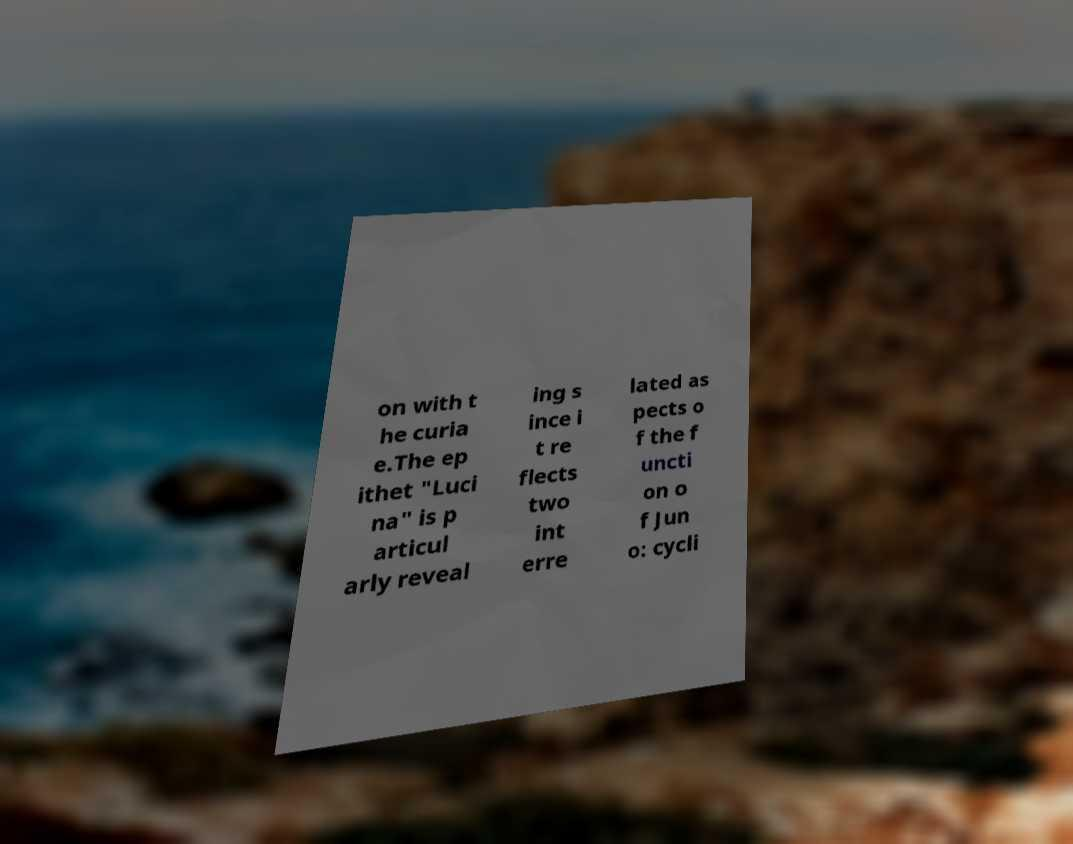I need the written content from this picture converted into text. Can you do that? on with t he curia e.The ep ithet "Luci na" is p articul arly reveal ing s ince i t re flects two int erre lated as pects o f the f uncti on o f Jun o: cycli 